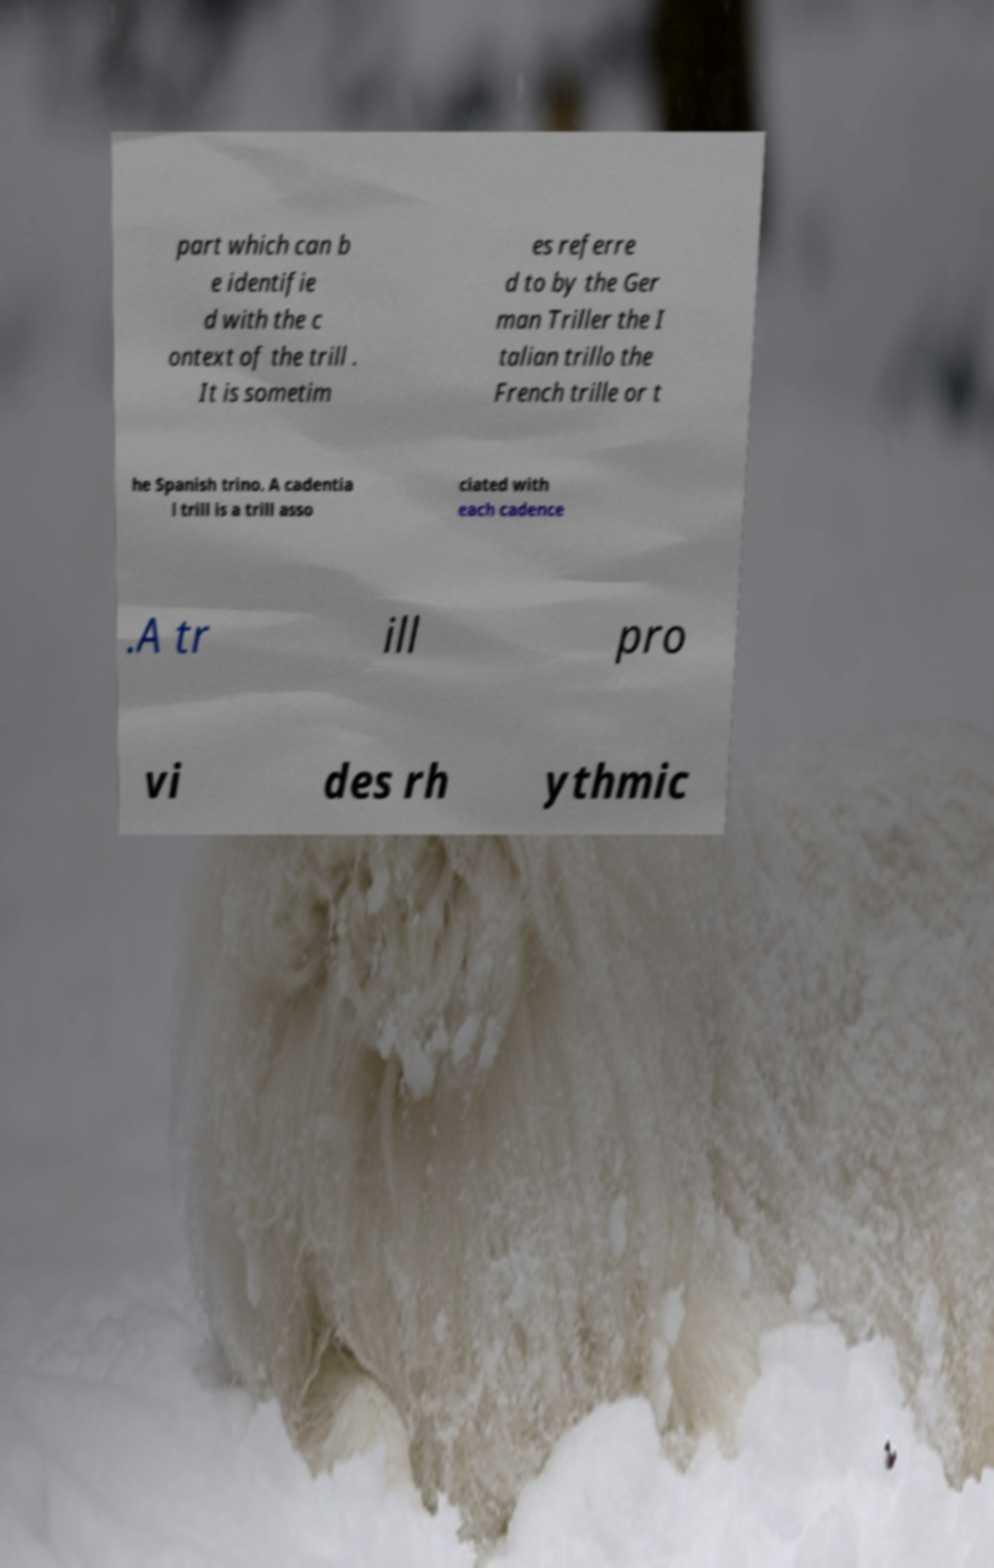There's text embedded in this image that I need extracted. Can you transcribe it verbatim? part which can b e identifie d with the c ontext of the trill . It is sometim es referre d to by the Ger man Triller the I talian trillo the French trille or t he Spanish trino. A cadentia l trill is a trill asso ciated with each cadence .A tr ill pro vi des rh ythmic 